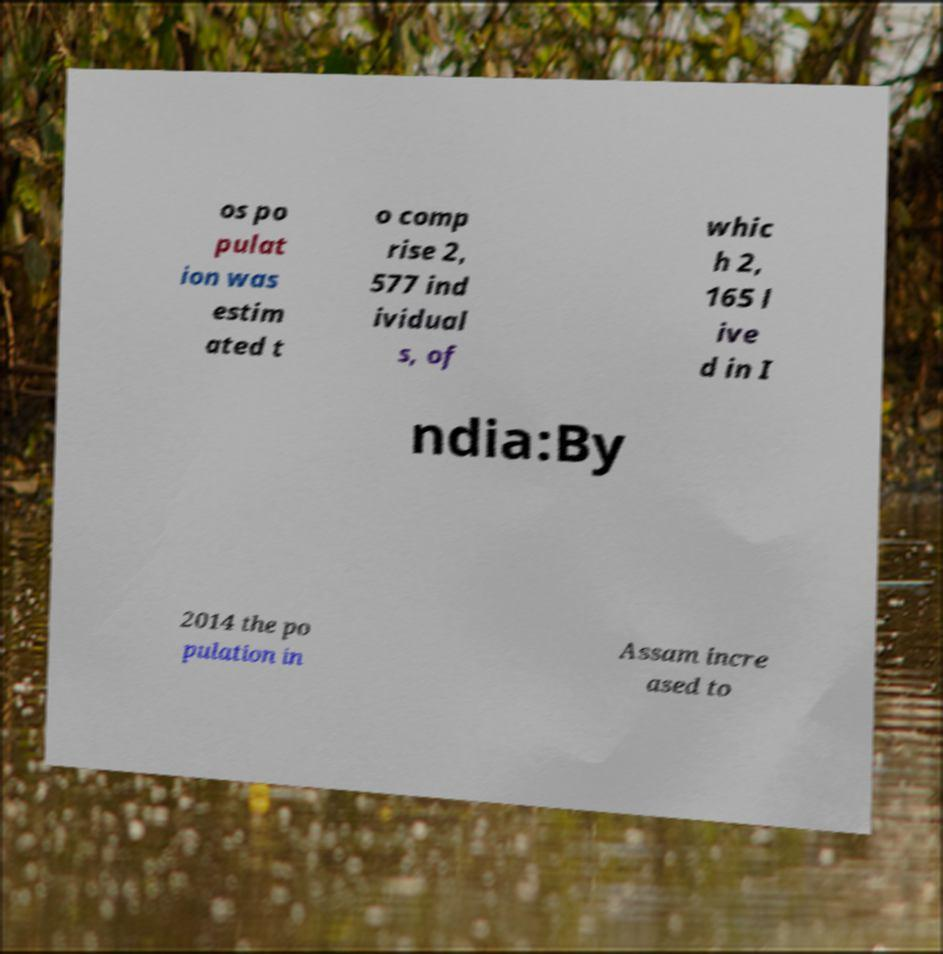Could you assist in decoding the text presented in this image and type it out clearly? os po pulat ion was estim ated t o comp rise 2, 577 ind ividual s, of whic h 2, 165 l ive d in I ndia:By 2014 the po pulation in Assam incre ased to 